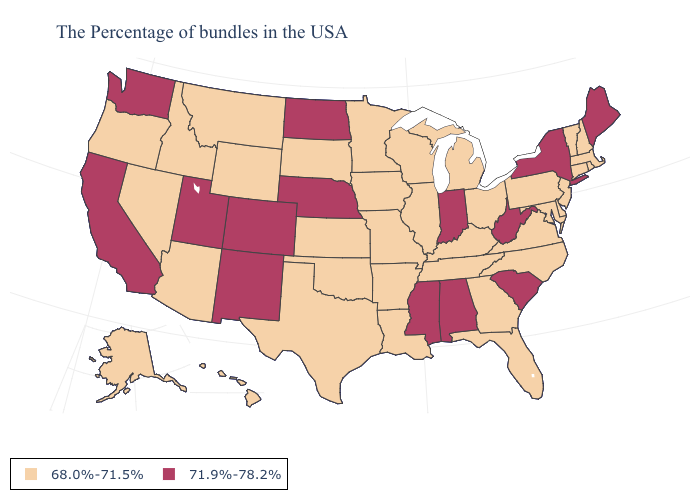Does the first symbol in the legend represent the smallest category?
Be succinct. Yes. Is the legend a continuous bar?
Keep it brief. No. Does Washington have the same value as Kansas?
Give a very brief answer. No. What is the value of Louisiana?
Give a very brief answer. 68.0%-71.5%. Which states have the lowest value in the USA?
Quick response, please. Massachusetts, Rhode Island, New Hampshire, Vermont, Connecticut, New Jersey, Delaware, Maryland, Pennsylvania, Virginia, North Carolina, Ohio, Florida, Georgia, Michigan, Kentucky, Tennessee, Wisconsin, Illinois, Louisiana, Missouri, Arkansas, Minnesota, Iowa, Kansas, Oklahoma, Texas, South Dakota, Wyoming, Montana, Arizona, Idaho, Nevada, Oregon, Alaska, Hawaii. What is the lowest value in the USA?
Give a very brief answer. 68.0%-71.5%. Name the states that have a value in the range 68.0%-71.5%?
Short answer required. Massachusetts, Rhode Island, New Hampshire, Vermont, Connecticut, New Jersey, Delaware, Maryland, Pennsylvania, Virginia, North Carolina, Ohio, Florida, Georgia, Michigan, Kentucky, Tennessee, Wisconsin, Illinois, Louisiana, Missouri, Arkansas, Minnesota, Iowa, Kansas, Oklahoma, Texas, South Dakota, Wyoming, Montana, Arizona, Idaho, Nevada, Oregon, Alaska, Hawaii. Name the states that have a value in the range 71.9%-78.2%?
Keep it brief. Maine, New York, South Carolina, West Virginia, Indiana, Alabama, Mississippi, Nebraska, North Dakota, Colorado, New Mexico, Utah, California, Washington. Name the states that have a value in the range 71.9%-78.2%?
Answer briefly. Maine, New York, South Carolina, West Virginia, Indiana, Alabama, Mississippi, Nebraska, North Dakota, Colorado, New Mexico, Utah, California, Washington. Name the states that have a value in the range 71.9%-78.2%?
Quick response, please. Maine, New York, South Carolina, West Virginia, Indiana, Alabama, Mississippi, Nebraska, North Dakota, Colorado, New Mexico, Utah, California, Washington. Name the states that have a value in the range 71.9%-78.2%?
Keep it brief. Maine, New York, South Carolina, West Virginia, Indiana, Alabama, Mississippi, Nebraska, North Dakota, Colorado, New Mexico, Utah, California, Washington. Does South Dakota have the highest value in the USA?
Write a very short answer. No. What is the value of Mississippi?
Concise answer only. 71.9%-78.2%. Name the states that have a value in the range 71.9%-78.2%?
Be succinct. Maine, New York, South Carolina, West Virginia, Indiana, Alabama, Mississippi, Nebraska, North Dakota, Colorado, New Mexico, Utah, California, Washington. Does New Mexico have the lowest value in the USA?
Give a very brief answer. No. 